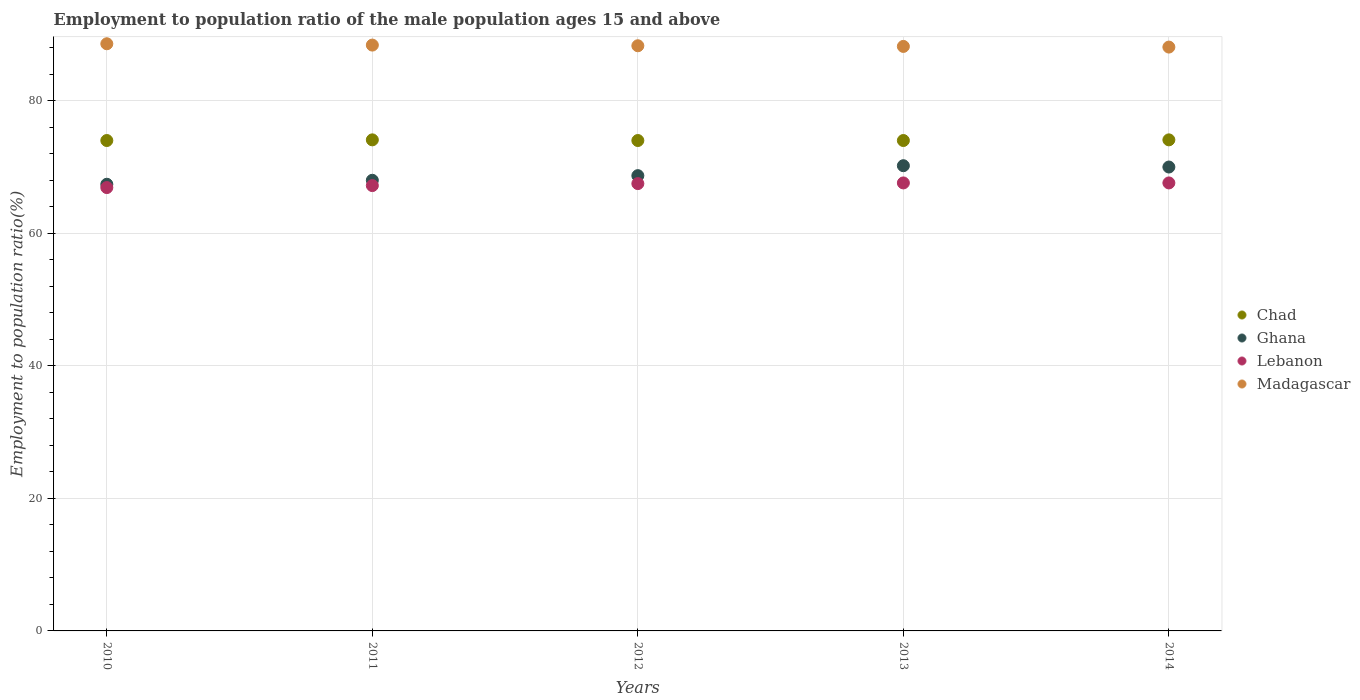How many different coloured dotlines are there?
Make the answer very short. 4. Is the number of dotlines equal to the number of legend labels?
Ensure brevity in your answer.  Yes. What is the employment to population ratio in Lebanon in 2013?
Offer a very short reply. 67.6. Across all years, what is the maximum employment to population ratio in Madagascar?
Provide a short and direct response. 88.6. Across all years, what is the minimum employment to population ratio in Madagascar?
Provide a succinct answer. 88.1. In which year was the employment to population ratio in Madagascar minimum?
Provide a short and direct response. 2014. What is the total employment to population ratio in Ghana in the graph?
Give a very brief answer. 344.3. What is the difference between the employment to population ratio in Chad in 2010 and that in 2014?
Ensure brevity in your answer.  -0.1. What is the difference between the employment to population ratio in Ghana in 2010 and the employment to population ratio in Madagascar in 2012?
Ensure brevity in your answer.  -20.9. What is the average employment to population ratio in Ghana per year?
Offer a terse response. 68.86. In the year 2013, what is the difference between the employment to population ratio in Lebanon and employment to population ratio in Chad?
Offer a terse response. -6.4. In how many years, is the employment to population ratio in Madagascar greater than 80 %?
Give a very brief answer. 5. What is the ratio of the employment to population ratio in Madagascar in 2012 to that in 2014?
Keep it short and to the point. 1. What is the difference between the highest and the second highest employment to population ratio in Madagascar?
Keep it short and to the point. 0.2. Is the sum of the employment to population ratio in Madagascar in 2011 and 2014 greater than the maximum employment to population ratio in Chad across all years?
Provide a short and direct response. Yes. Does the employment to population ratio in Chad monotonically increase over the years?
Provide a succinct answer. No. Is the employment to population ratio in Madagascar strictly less than the employment to population ratio in Ghana over the years?
Provide a short and direct response. No. How many dotlines are there?
Keep it short and to the point. 4. Are the values on the major ticks of Y-axis written in scientific E-notation?
Keep it short and to the point. No. Does the graph contain grids?
Offer a very short reply. Yes. How many legend labels are there?
Your answer should be very brief. 4. What is the title of the graph?
Ensure brevity in your answer.  Employment to population ratio of the male population ages 15 and above. What is the label or title of the X-axis?
Provide a short and direct response. Years. What is the Employment to population ratio(%) in Chad in 2010?
Offer a very short reply. 74. What is the Employment to population ratio(%) in Ghana in 2010?
Your answer should be very brief. 67.4. What is the Employment to population ratio(%) of Lebanon in 2010?
Keep it short and to the point. 66.9. What is the Employment to population ratio(%) of Madagascar in 2010?
Your response must be concise. 88.6. What is the Employment to population ratio(%) in Chad in 2011?
Offer a very short reply. 74.1. What is the Employment to population ratio(%) of Ghana in 2011?
Ensure brevity in your answer.  68. What is the Employment to population ratio(%) in Lebanon in 2011?
Offer a very short reply. 67.2. What is the Employment to population ratio(%) in Madagascar in 2011?
Offer a very short reply. 88.4. What is the Employment to population ratio(%) in Ghana in 2012?
Ensure brevity in your answer.  68.7. What is the Employment to population ratio(%) in Lebanon in 2012?
Your answer should be very brief. 67.5. What is the Employment to population ratio(%) of Madagascar in 2012?
Give a very brief answer. 88.3. What is the Employment to population ratio(%) in Chad in 2013?
Offer a very short reply. 74. What is the Employment to population ratio(%) in Ghana in 2013?
Provide a succinct answer. 70.2. What is the Employment to population ratio(%) of Lebanon in 2013?
Provide a succinct answer. 67.6. What is the Employment to population ratio(%) of Madagascar in 2013?
Make the answer very short. 88.2. What is the Employment to population ratio(%) of Chad in 2014?
Your answer should be very brief. 74.1. What is the Employment to population ratio(%) in Ghana in 2014?
Offer a very short reply. 70. What is the Employment to population ratio(%) of Lebanon in 2014?
Give a very brief answer. 67.6. What is the Employment to population ratio(%) in Madagascar in 2014?
Provide a succinct answer. 88.1. Across all years, what is the maximum Employment to population ratio(%) of Chad?
Your response must be concise. 74.1. Across all years, what is the maximum Employment to population ratio(%) in Ghana?
Your answer should be very brief. 70.2. Across all years, what is the maximum Employment to population ratio(%) in Lebanon?
Your answer should be compact. 67.6. Across all years, what is the maximum Employment to population ratio(%) of Madagascar?
Give a very brief answer. 88.6. Across all years, what is the minimum Employment to population ratio(%) of Ghana?
Your answer should be compact. 67.4. Across all years, what is the minimum Employment to population ratio(%) of Lebanon?
Provide a short and direct response. 66.9. Across all years, what is the minimum Employment to population ratio(%) in Madagascar?
Provide a short and direct response. 88.1. What is the total Employment to population ratio(%) in Chad in the graph?
Offer a very short reply. 370.2. What is the total Employment to population ratio(%) of Ghana in the graph?
Offer a very short reply. 344.3. What is the total Employment to population ratio(%) of Lebanon in the graph?
Provide a short and direct response. 336.8. What is the total Employment to population ratio(%) of Madagascar in the graph?
Provide a succinct answer. 441.6. What is the difference between the Employment to population ratio(%) in Lebanon in 2010 and that in 2011?
Your answer should be compact. -0.3. What is the difference between the Employment to population ratio(%) of Madagascar in 2010 and that in 2011?
Your answer should be compact. 0.2. What is the difference between the Employment to population ratio(%) of Chad in 2010 and that in 2012?
Offer a very short reply. 0. What is the difference between the Employment to population ratio(%) of Ghana in 2010 and that in 2012?
Make the answer very short. -1.3. What is the difference between the Employment to population ratio(%) in Lebanon in 2010 and that in 2012?
Ensure brevity in your answer.  -0.6. What is the difference between the Employment to population ratio(%) in Madagascar in 2010 and that in 2012?
Ensure brevity in your answer.  0.3. What is the difference between the Employment to population ratio(%) of Ghana in 2010 and that in 2013?
Provide a short and direct response. -2.8. What is the difference between the Employment to population ratio(%) of Madagascar in 2010 and that in 2013?
Provide a short and direct response. 0.4. What is the difference between the Employment to population ratio(%) in Madagascar in 2010 and that in 2014?
Your answer should be compact. 0.5. What is the difference between the Employment to population ratio(%) in Chad in 2011 and that in 2012?
Keep it short and to the point. 0.1. What is the difference between the Employment to population ratio(%) of Lebanon in 2011 and that in 2012?
Your answer should be compact. -0.3. What is the difference between the Employment to population ratio(%) in Chad in 2011 and that in 2013?
Make the answer very short. 0.1. What is the difference between the Employment to population ratio(%) in Lebanon in 2011 and that in 2013?
Make the answer very short. -0.4. What is the difference between the Employment to population ratio(%) of Madagascar in 2011 and that in 2013?
Provide a short and direct response. 0.2. What is the difference between the Employment to population ratio(%) in Ghana in 2011 and that in 2014?
Provide a short and direct response. -2. What is the difference between the Employment to population ratio(%) in Lebanon in 2011 and that in 2014?
Your answer should be compact. -0.4. What is the difference between the Employment to population ratio(%) in Chad in 2012 and that in 2013?
Give a very brief answer. 0. What is the difference between the Employment to population ratio(%) in Ghana in 2012 and that in 2013?
Offer a very short reply. -1.5. What is the difference between the Employment to population ratio(%) of Madagascar in 2012 and that in 2013?
Give a very brief answer. 0.1. What is the difference between the Employment to population ratio(%) in Chad in 2012 and that in 2014?
Your response must be concise. -0.1. What is the difference between the Employment to population ratio(%) of Ghana in 2012 and that in 2014?
Offer a terse response. -1.3. What is the difference between the Employment to population ratio(%) of Lebanon in 2012 and that in 2014?
Provide a short and direct response. -0.1. What is the difference between the Employment to population ratio(%) of Madagascar in 2012 and that in 2014?
Make the answer very short. 0.2. What is the difference between the Employment to population ratio(%) of Ghana in 2013 and that in 2014?
Your response must be concise. 0.2. What is the difference between the Employment to population ratio(%) of Madagascar in 2013 and that in 2014?
Your answer should be compact. 0.1. What is the difference between the Employment to population ratio(%) in Chad in 2010 and the Employment to population ratio(%) in Madagascar in 2011?
Your response must be concise. -14.4. What is the difference between the Employment to population ratio(%) in Ghana in 2010 and the Employment to population ratio(%) in Madagascar in 2011?
Provide a succinct answer. -21. What is the difference between the Employment to population ratio(%) in Lebanon in 2010 and the Employment to population ratio(%) in Madagascar in 2011?
Provide a succinct answer. -21.5. What is the difference between the Employment to population ratio(%) of Chad in 2010 and the Employment to population ratio(%) of Ghana in 2012?
Offer a terse response. 5.3. What is the difference between the Employment to population ratio(%) in Chad in 2010 and the Employment to population ratio(%) in Madagascar in 2012?
Provide a short and direct response. -14.3. What is the difference between the Employment to population ratio(%) of Ghana in 2010 and the Employment to population ratio(%) of Madagascar in 2012?
Keep it short and to the point. -20.9. What is the difference between the Employment to population ratio(%) of Lebanon in 2010 and the Employment to population ratio(%) of Madagascar in 2012?
Provide a short and direct response. -21.4. What is the difference between the Employment to population ratio(%) in Chad in 2010 and the Employment to population ratio(%) in Madagascar in 2013?
Ensure brevity in your answer.  -14.2. What is the difference between the Employment to population ratio(%) in Ghana in 2010 and the Employment to population ratio(%) in Madagascar in 2013?
Ensure brevity in your answer.  -20.8. What is the difference between the Employment to population ratio(%) in Lebanon in 2010 and the Employment to population ratio(%) in Madagascar in 2013?
Provide a succinct answer. -21.3. What is the difference between the Employment to population ratio(%) in Chad in 2010 and the Employment to population ratio(%) in Ghana in 2014?
Ensure brevity in your answer.  4. What is the difference between the Employment to population ratio(%) in Chad in 2010 and the Employment to population ratio(%) in Madagascar in 2014?
Offer a very short reply. -14.1. What is the difference between the Employment to population ratio(%) in Ghana in 2010 and the Employment to population ratio(%) in Madagascar in 2014?
Ensure brevity in your answer.  -20.7. What is the difference between the Employment to population ratio(%) of Lebanon in 2010 and the Employment to population ratio(%) of Madagascar in 2014?
Your answer should be very brief. -21.2. What is the difference between the Employment to population ratio(%) in Chad in 2011 and the Employment to population ratio(%) in Ghana in 2012?
Your answer should be compact. 5.4. What is the difference between the Employment to population ratio(%) of Ghana in 2011 and the Employment to population ratio(%) of Lebanon in 2012?
Give a very brief answer. 0.5. What is the difference between the Employment to population ratio(%) of Ghana in 2011 and the Employment to population ratio(%) of Madagascar in 2012?
Your answer should be very brief. -20.3. What is the difference between the Employment to population ratio(%) of Lebanon in 2011 and the Employment to population ratio(%) of Madagascar in 2012?
Provide a succinct answer. -21.1. What is the difference between the Employment to population ratio(%) of Chad in 2011 and the Employment to population ratio(%) of Lebanon in 2013?
Provide a short and direct response. 6.5. What is the difference between the Employment to population ratio(%) of Chad in 2011 and the Employment to population ratio(%) of Madagascar in 2013?
Offer a very short reply. -14.1. What is the difference between the Employment to population ratio(%) in Ghana in 2011 and the Employment to population ratio(%) in Madagascar in 2013?
Provide a succinct answer. -20.2. What is the difference between the Employment to population ratio(%) in Chad in 2011 and the Employment to population ratio(%) in Madagascar in 2014?
Offer a very short reply. -14. What is the difference between the Employment to population ratio(%) of Ghana in 2011 and the Employment to population ratio(%) of Lebanon in 2014?
Keep it short and to the point. 0.4. What is the difference between the Employment to population ratio(%) of Ghana in 2011 and the Employment to population ratio(%) of Madagascar in 2014?
Your response must be concise. -20.1. What is the difference between the Employment to population ratio(%) of Lebanon in 2011 and the Employment to population ratio(%) of Madagascar in 2014?
Give a very brief answer. -20.9. What is the difference between the Employment to population ratio(%) in Chad in 2012 and the Employment to population ratio(%) in Lebanon in 2013?
Provide a short and direct response. 6.4. What is the difference between the Employment to population ratio(%) of Ghana in 2012 and the Employment to population ratio(%) of Lebanon in 2013?
Give a very brief answer. 1.1. What is the difference between the Employment to population ratio(%) of Ghana in 2012 and the Employment to population ratio(%) of Madagascar in 2013?
Your answer should be compact. -19.5. What is the difference between the Employment to population ratio(%) in Lebanon in 2012 and the Employment to population ratio(%) in Madagascar in 2013?
Your answer should be very brief. -20.7. What is the difference between the Employment to population ratio(%) of Chad in 2012 and the Employment to population ratio(%) of Lebanon in 2014?
Your response must be concise. 6.4. What is the difference between the Employment to population ratio(%) in Chad in 2012 and the Employment to population ratio(%) in Madagascar in 2014?
Offer a very short reply. -14.1. What is the difference between the Employment to population ratio(%) of Ghana in 2012 and the Employment to population ratio(%) of Madagascar in 2014?
Your answer should be compact. -19.4. What is the difference between the Employment to population ratio(%) of Lebanon in 2012 and the Employment to population ratio(%) of Madagascar in 2014?
Your answer should be very brief. -20.6. What is the difference between the Employment to population ratio(%) of Chad in 2013 and the Employment to population ratio(%) of Ghana in 2014?
Make the answer very short. 4. What is the difference between the Employment to population ratio(%) of Chad in 2013 and the Employment to population ratio(%) of Lebanon in 2014?
Your answer should be compact. 6.4. What is the difference between the Employment to population ratio(%) in Chad in 2013 and the Employment to population ratio(%) in Madagascar in 2014?
Make the answer very short. -14.1. What is the difference between the Employment to population ratio(%) of Ghana in 2013 and the Employment to population ratio(%) of Madagascar in 2014?
Offer a terse response. -17.9. What is the difference between the Employment to population ratio(%) of Lebanon in 2013 and the Employment to population ratio(%) of Madagascar in 2014?
Offer a terse response. -20.5. What is the average Employment to population ratio(%) in Chad per year?
Your answer should be compact. 74.04. What is the average Employment to population ratio(%) of Ghana per year?
Provide a short and direct response. 68.86. What is the average Employment to population ratio(%) of Lebanon per year?
Your answer should be compact. 67.36. What is the average Employment to population ratio(%) in Madagascar per year?
Provide a succinct answer. 88.32. In the year 2010, what is the difference between the Employment to population ratio(%) in Chad and Employment to population ratio(%) in Madagascar?
Your answer should be very brief. -14.6. In the year 2010, what is the difference between the Employment to population ratio(%) in Ghana and Employment to population ratio(%) in Lebanon?
Offer a very short reply. 0.5. In the year 2010, what is the difference between the Employment to population ratio(%) of Ghana and Employment to population ratio(%) of Madagascar?
Provide a succinct answer. -21.2. In the year 2010, what is the difference between the Employment to population ratio(%) of Lebanon and Employment to population ratio(%) of Madagascar?
Your response must be concise. -21.7. In the year 2011, what is the difference between the Employment to population ratio(%) of Chad and Employment to population ratio(%) of Ghana?
Offer a very short reply. 6.1. In the year 2011, what is the difference between the Employment to population ratio(%) in Chad and Employment to population ratio(%) in Lebanon?
Keep it short and to the point. 6.9. In the year 2011, what is the difference between the Employment to population ratio(%) of Chad and Employment to population ratio(%) of Madagascar?
Keep it short and to the point. -14.3. In the year 2011, what is the difference between the Employment to population ratio(%) in Ghana and Employment to population ratio(%) in Madagascar?
Give a very brief answer. -20.4. In the year 2011, what is the difference between the Employment to population ratio(%) of Lebanon and Employment to population ratio(%) of Madagascar?
Offer a terse response. -21.2. In the year 2012, what is the difference between the Employment to population ratio(%) of Chad and Employment to population ratio(%) of Lebanon?
Ensure brevity in your answer.  6.5. In the year 2012, what is the difference between the Employment to population ratio(%) in Chad and Employment to population ratio(%) in Madagascar?
Offer a very short reply. -14.3. In the year 2012, what is the difference between the Employment to population ratio(%) of Ghana and Employment to population ratio(%) of Lebanon?
Offer a terse response. 1.2. In the year 2012, what is the difference between the Employment to population ratio(%) in Ghana and Employment to population ratio(%) in Madagascar?
Keep it short and to the point. -19.6. In the year 2012, what is the difference between the Employment to population ratio(%) in Lebanon and Employment to population ratio(%) in Madagascar?
Offer a very short reply. -20.8. In the year 2013, what is the difference between the Employment to population ratio(%) in Chad and Employment to population ratio(%) in Ghana?
Ensure brevity in your answer.  3.8. In the year 2013, what is the difference between the Employment to population ratio(%) in Chad and Employment to population ratio(%) in Lebanon?
Offer a very short reply. 6.4. In the year 2013, what is the difference between the Employment to population ratio(%) in Chad and Employment to population ratio(%) in Madagascar?
Give a very brief answer. -14.2. In the year 2013, what is the difference between the Employment to population ratio(%) of Ghana and Employment to population ratio(%) of Lebanon?
Your answer should be very brief. 2.6. In the year 2013, what is the difference between the Employment to population ratio(%) of Ghana and Employment to population ratio(%) of Madagascar?
Offer a very short reply. -18. In the year 2013, what is the difference between the Employment to population ratio(%) in Lebanon and Employment to population ratio(%) in Madagascar?
Make the answer very short. -20.6. In the year 2014, what is the difference between the Employment to population ratio(%) in Chad and Employment to population ratio(%) in Lebanon?
Provide a short and direct response. 6.5. In the year 2014, what is the difference between the Employment to population ratio(%) of Ghana and Employment to population ratio(%) of Lebanon?
Offer a very short reply. 2.4. In the year 2014, what is the difference between the Employment to population ratio(%) in Ghana and Employment to population ratio(%) in Madagascar?
Provide a succinct answer. -18.1. In the year 2014, what is the difference between the Employment to population ratio(%) in Lebanon and Employment to population ratio(%) in Madagascar?
Offer a terse response. -20.5. What is the ratio of the Employment to population ratio(%) of Chad in 2010 to that in 2011?
Your answer should be very brief. 1. What is the ratio of the Employment to population ratio(%) of Lebanon in 2010 to that in 2011?
Your response must be concise. 1. What is the ratio of the Employment to population ratio(%) of Ghana in 2010 to that in 2012?
Provide a short and direct response. 0.98. What is the ratio of the Employment to population ratio(%) in Lebanon in 2010 to that in 2012?
Provide a short and direct response. 0.99. What is the ratio of the Employment to population ratio(%) in Madagascar in 2010 to that in 2012?
Give a very brief answer. 1. What is the ratio of the Employment to population ratio(%) in Chad in 2010 to that in 2013?
Your response must be concise. 1. What is the ratio of the Employment to population ratio(%) in Ghana in 2010 to that in 2013?
Provide a succinct answer. 0.96. What is the ratio of the Employment to population ratio(%) in Ghana in 2010 to that in 2014?
Make the answer very short. 0.96. What is the ratio of the Employment to population ratio(%) in Madagascar in 2010 to that in 2014?
Your response must be concise. 1.01. What is the ratio of the Employment to population ratio(%) of Ghana in 2011 to that in 2012?
Your response must be concise. 0.99. What is the ratio of the Employment to population ratio(%) of Ghana in 2011 to that in 2013?
Keep it short and to the point. 0.97. What is the ratio of the Employment to population ratio(%) in Madagascar in 2011 to that in 2013?
Your answer should be compact. 1. What is the ratio of the Employment to population ratio(%) in Ghana in 2011 to that in 2014?
Offer a terse response. 0.97. What is the ratio of the Employment to population ratio(%) in Madagascar in 2011 to that in 2014?
Your answer should be compact. 1. What is the ratio of the Employment to population ratio(%) in Chad in 2012 to that in 2013?
Offer a very short reply. 1. What is the ratio of the Employment to population ratio(%) in Ghana in 2012 to that in 2013?
Make the answer very short. 0.98. What is the ratio of the Employment to population ratio(%) of Ghana in 2012 to that in 2014?
Your response must be concise. 0.98. What is the ratio of the Employment to population ratio(%) in Lebanon in 2012 to that in 2014?
Your answer should be compact. 1. What is the ratio of the Employment to population ratio(%) of Madagascar in 2012 to that in 2014?
Offer a terse response. 1. What is the ratio of the Employment to population ratio(%) of Chad in 2013 to that in 2014?
Offer a very short reply. 1. What is the ratio of the Employment to population ratio(%) in Ghana in 2013 to that in 2014?
Give a very brief answer. 1. What is the difference between the highest and the second highest Employment to population ratio(%) of Ghana?
Provide a short and direct response. 0.2. What is the difference between the highest and the second highest Employment to population ratio(%) of Lebanon?
Provide a succinct answer. 0. What is the difference between the highest and the lowest Employment to population ratio(%) of Ghana?
Give a very brief answer. 2.8. What is the difference between the highest and the lowest Employment to population ratio(%) of Madagascar?
Give a very brief answer. 0.5. 